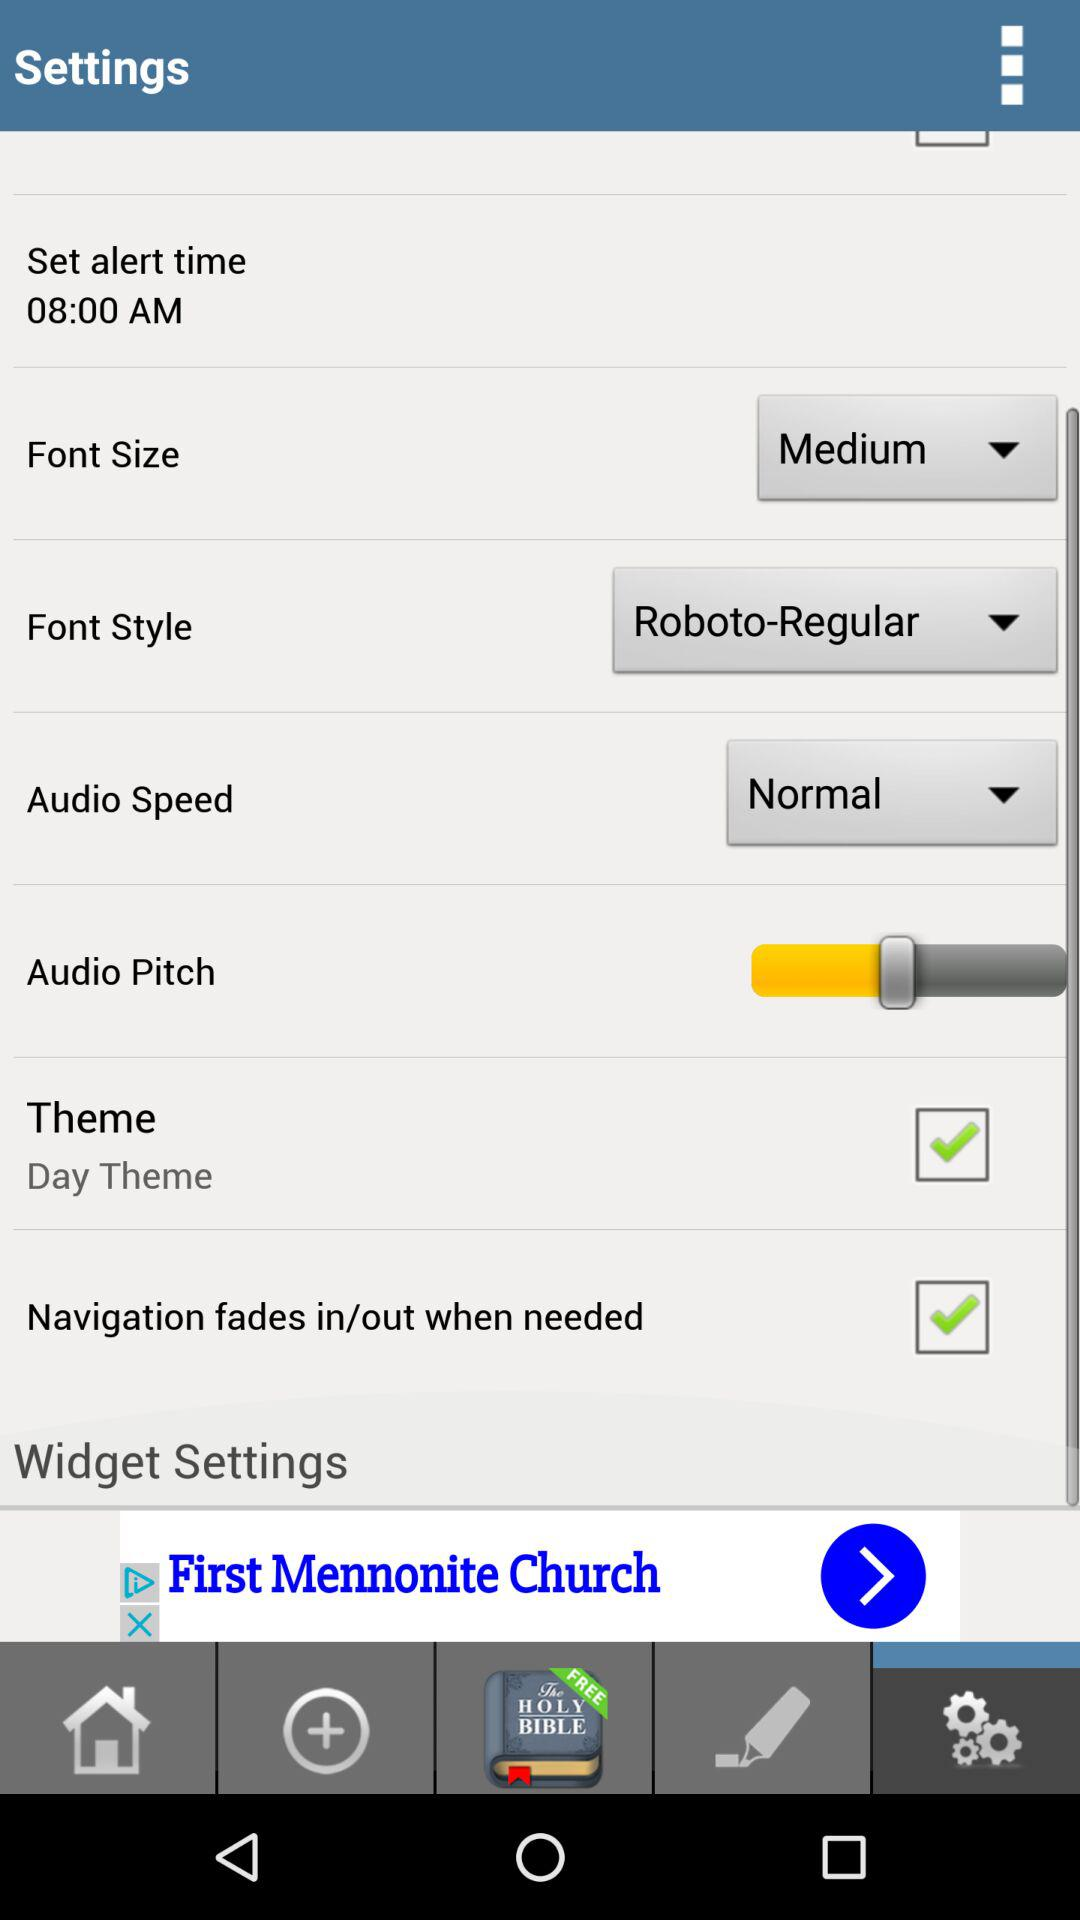Which font style is selected? The font style is "Roboto-Regular". 